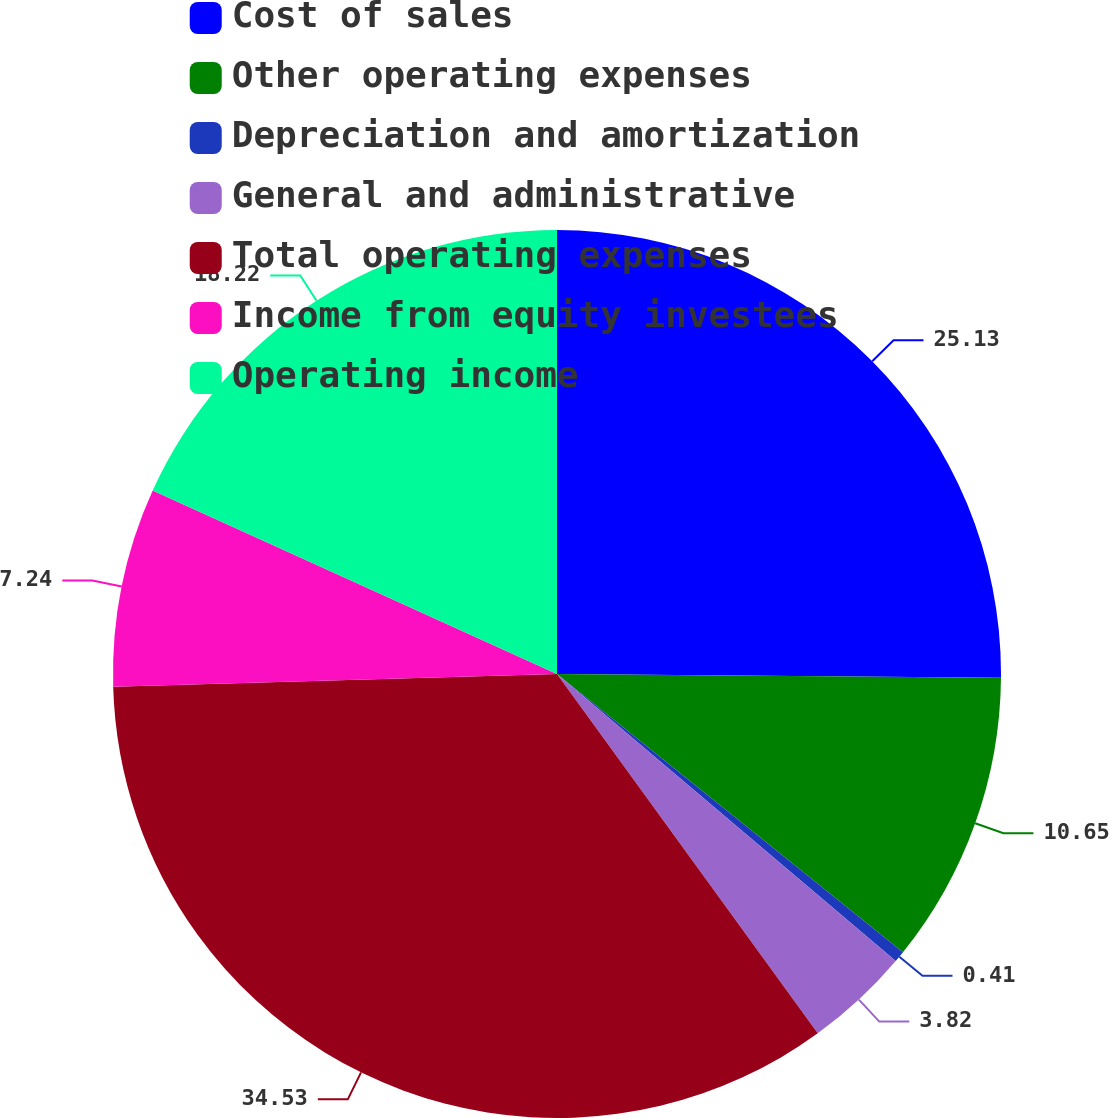<chart> <loc_0><loc_0><loc_500><loc_500><pie_chart><fcel>Cost of sales<fcel>Other operating expenses<fcel>Depreciation and amortization<fcel>General and administrative<fcel>Total operating expenses<fcel>Income from equity investees<fcel>Operating income<nl><fcel>25.13%<fcel>10.65%<fcel>0.41%<fcel>3.82%<fcel>34.53%<fcel>7.24%<fcel>18.22%<nl></chart> 